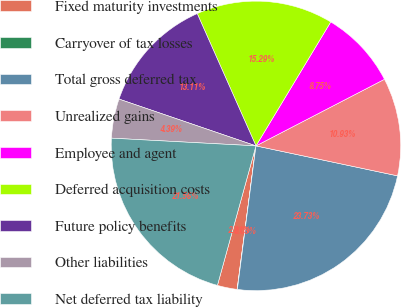Convert chart. <chart><loc_0><loc_0><loc_500><loc_500><pie_chart><fcel>Fixed maturity investments<fcel>Carryover of tax losses<fcel>Total gross deferred tax<fcel>Unrealized gains<fcel>Employee and agent<fcel>Deferred acquisition costs<fcel>Future policy benefits<fcel>Other liabilities<fcel>Net deferred tax liability<nl><fcel>2.21%<fcel>0.03%<fcel>23.73%<fcel>10.93%<fcel>8.75%<fcel>15.29%<fcel>13.11%<fcel>4.39%<fcel>21.56%<nl></chart> 